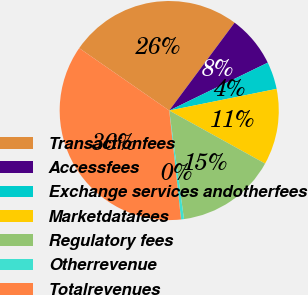Convert chart. <chart><loc_0><loc_0><loc_500><loc_500><pie_chart><fcel>Transactionfees<fcel>Accessfees<fcel>Exchange services andotherfees<fcel>Marketdatafees<fcel>Regulatory fees<fcel>Otherrevenue<fcel>Totalrevenues<nl><fcel>25.53%<fcel>7.62%<fcel>4.03%<fcel>11.21%<fcel>14.81%<fcel>0.43%<fcel>36.37%<nl></chart> 